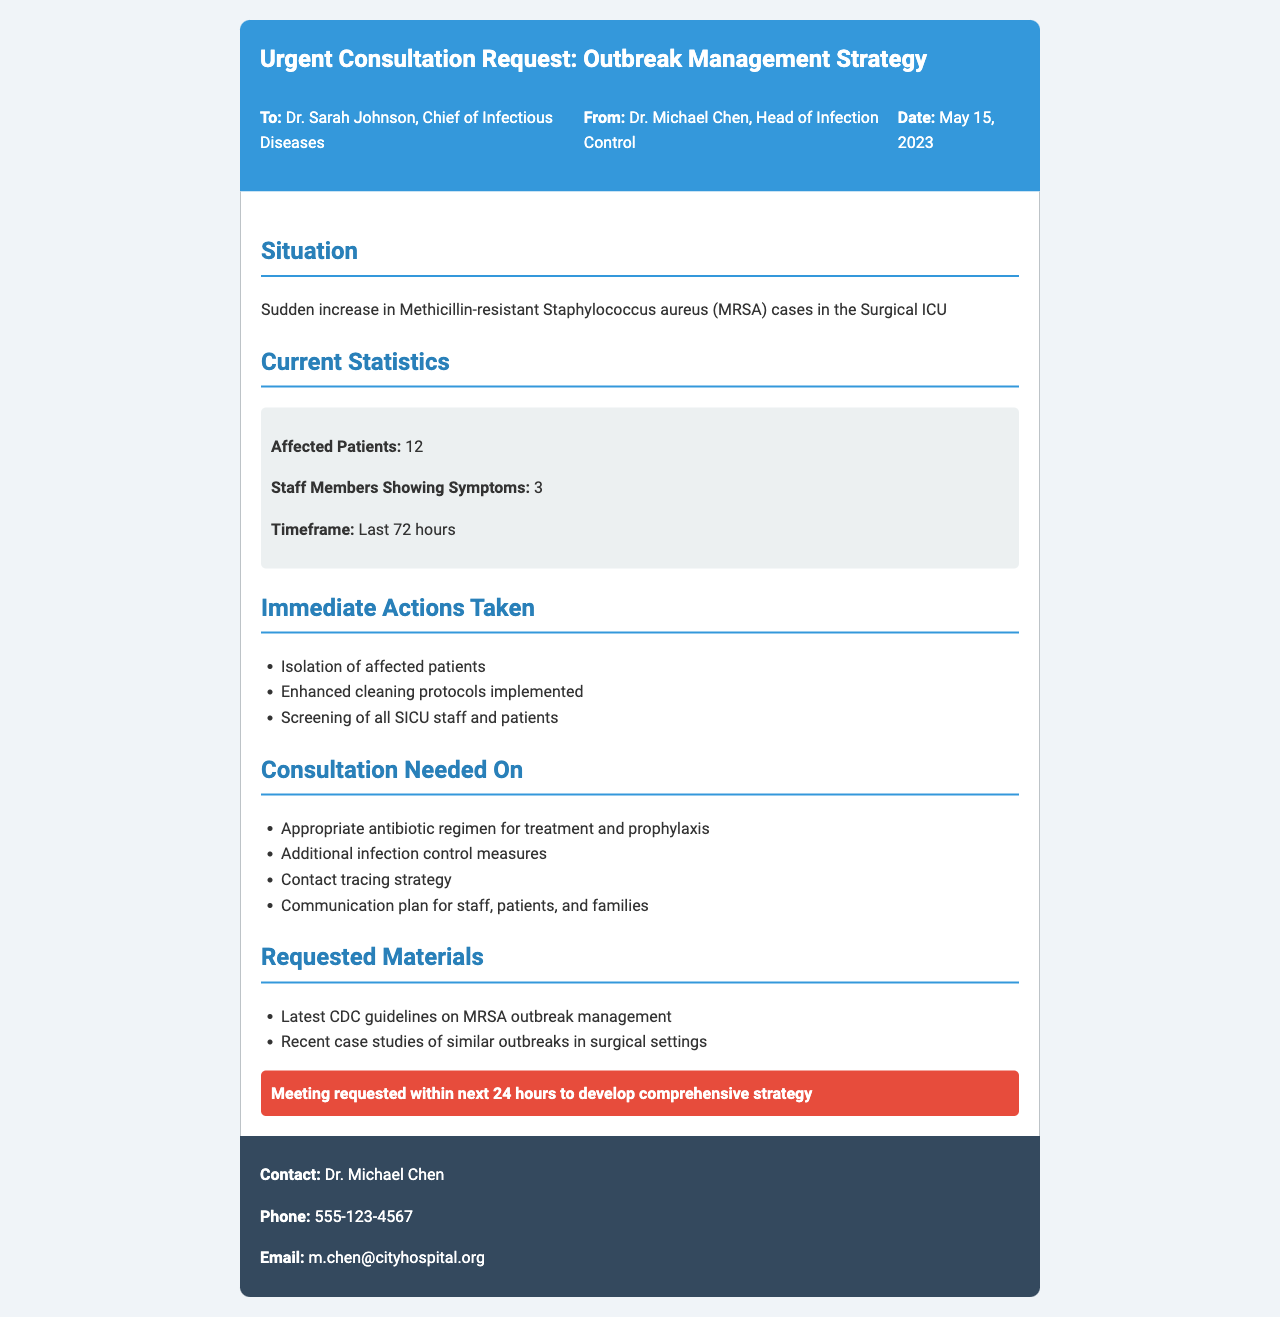what is the name of the person sending the fax? The person sending the fax is identified at the top of the document as Dr. Michael Chen.
Answer: Dr. Michael Chen what is the date of the fax? The date can be found in the header section of the document, shown as May 15, 2023.
Answer: May 15, 2023 how many affected patients are mentioned? The document states that there are 12 affected patients in the Surgical ICU.
Answer: 12 what symptoms are being reported among staff members? The document notes that 3 staff members are showing symptoms related to the outbreak.
Answer: 3 what immediate action involves the staff? The document lists "Screening of all SICU staff and patients" as an immediate action taken.
Answer: Screening of all SICU staff what is the urgency of the consultation request? The document explicitly states that a meeting is requested within the next 24 hours to develop a comprehensive strategy.
Answer: within next 24 hours what guidelines are requested as part of the materials? The requested materials include "Latest CDC guidelines on MRSA outbreak management."
Answer: Latest CDC guidelines on MRSA outbreak management what is the email address of the sender? The email address of the sender is found in the footer of the document as m.chen@cityhospital.org.
Answer: m.chen@cityhospital.org what additional measure is included in the consultation needed on? The document specifies "Additional infection control measures" as one of the consultation needs.
Answer: Additional infection control measures 